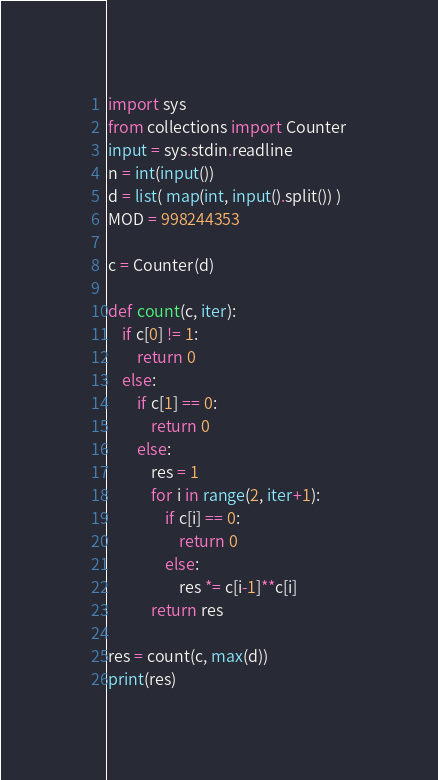Convert code to text. <code><loc_0><loc_0><loc_500><loc_500><_Python_>import sys
from collections import Counter
input = sys.stdin.readline
n = int(input())
d = list( map(int, input().split()) )
MOD = 998244353

c = Counter(d)

def count(c, iter):
    if c[0] != 1:
        return 0
    else:
        if c[1] == 0:
            return 0
        else:
            res = 1
            for i in range(2, iter+1):
                if c[i] == 0:
                    return 0
                else:
                    res *= c[i-1]**c[i]
            return res

res = count(c, max(d))
print(res)</code> 